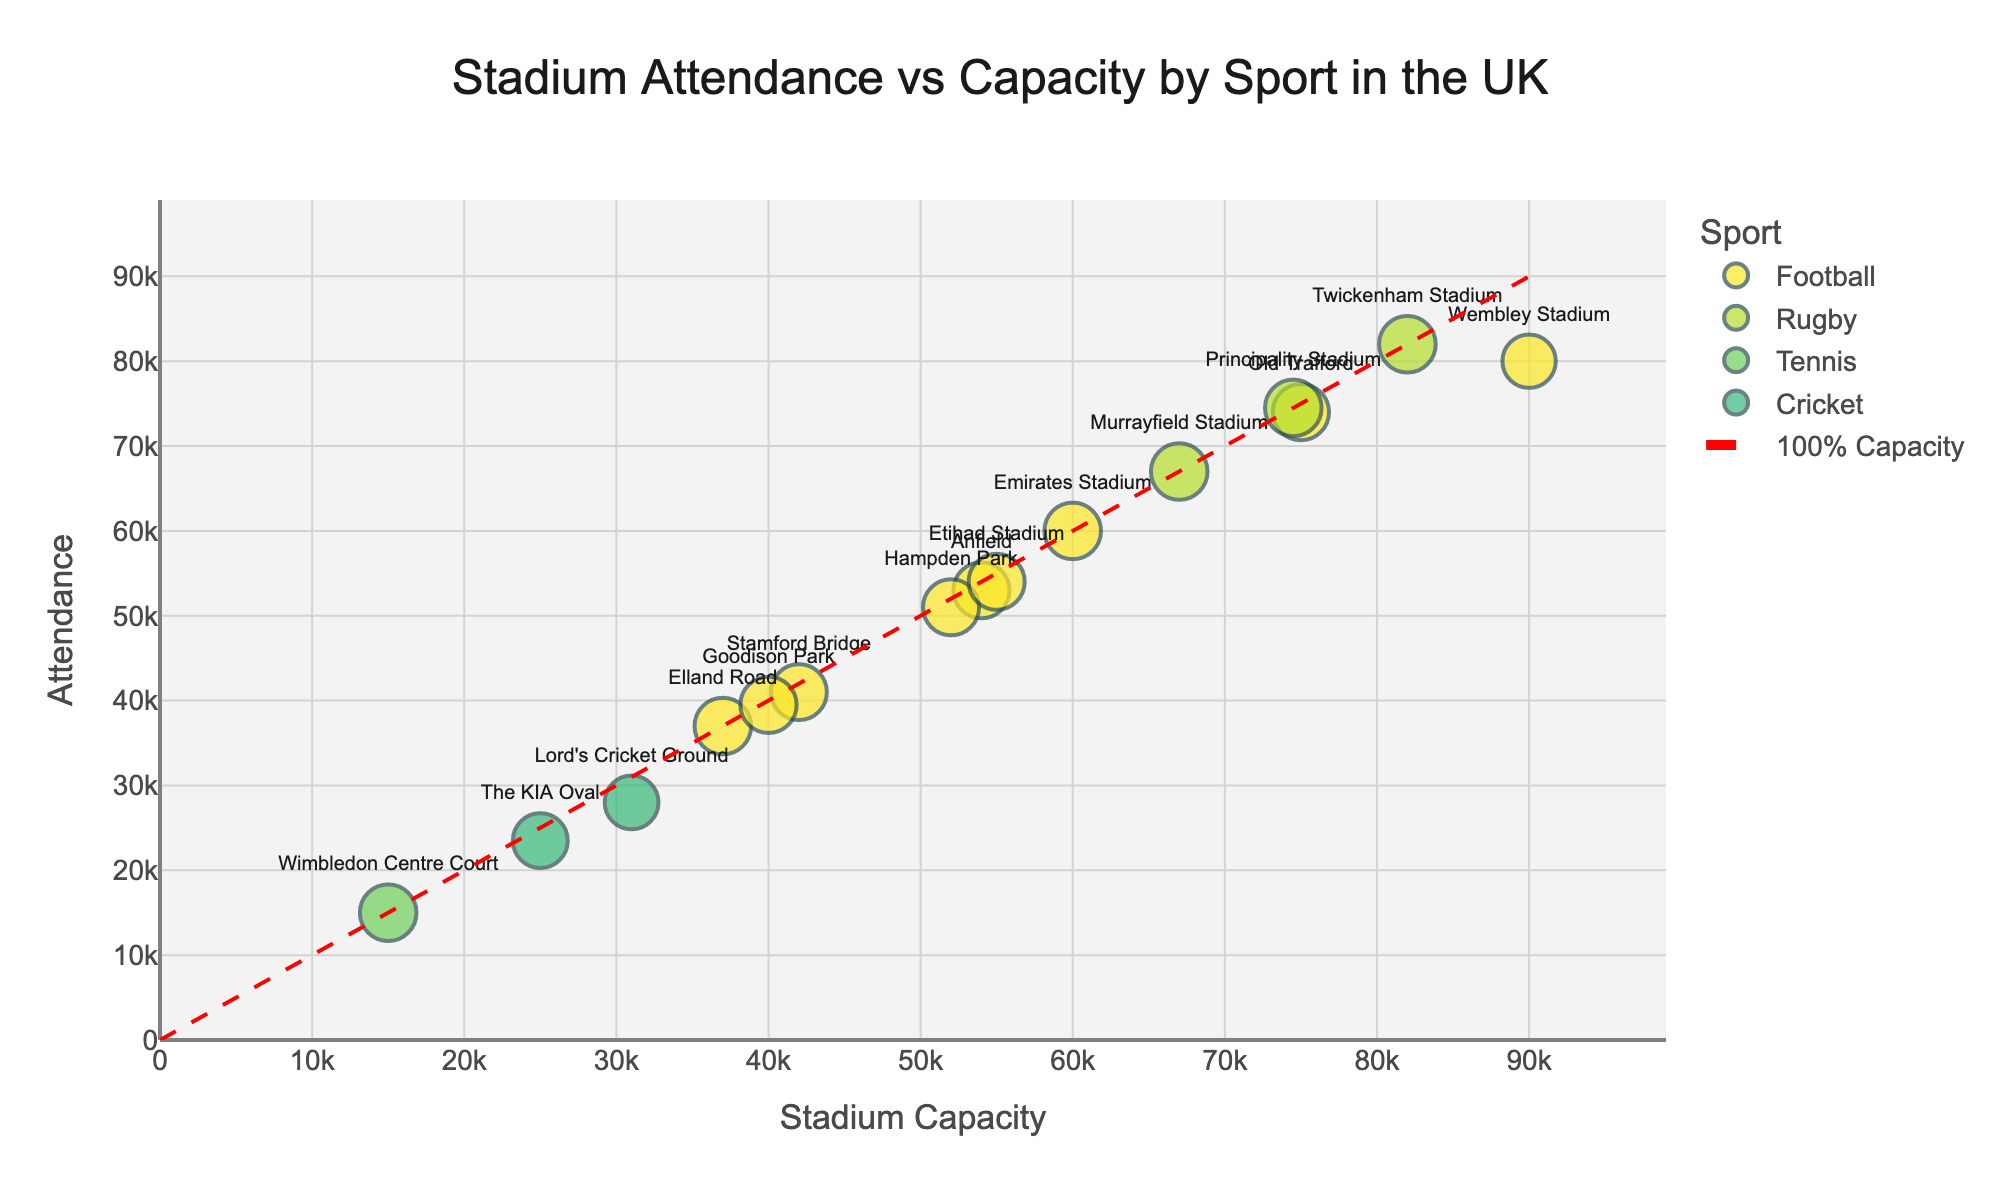What's the title of the grouped scatter plot? The title can be found prominently displayed at the top of the plot.
Answer: Stadium Attendance vs Capacity by Sport in the UK How many sports categories are represented in the plot? Each sport has a unique color. Identify the number of different colors in the legend.
Answer: Four (Football, Rugby, Tennis, Cricket) Which stadium has the highest attendance figure? By looking at the highest y-axis value of the data points, we can identify the stadium with the highest attendance.
Answer: Twickenham Stadium Is there any sport category where all represented stadiums filled 100% of their capacity? Check the data points with 100% capacity filled (diagonal line) and see if all stadiums for any sport fall on this line.
Answer: Tennis (Wimbledon Centre Court) Which stadium had the lowest percentage of its capacity filled, and what was that percentage? Find the data point farthest below the 100% capacity diagonal line. The percentage is also indicated by the size of the point (smaller size indicates lower capacity filled).
Answer: Lord's Cricket Ground, 90.32% Compare the attendance of Wembley Stadium to Old Trafford during the 2022/2023 season. Which was higher and by how much? Look at the y-axis values of both points during the 2022/2023 season for Football. Subtract the smaller from the larger value.
Answer: Wembley Stadium by 6000 Which rugby stadium had the highest attendance? Identify the highest point within the Rugby category.
Answer: Twickenham Stadium How does the attendance at the Emirates Stadium compare to that at Anfield? Check the y-axis values for both data points and compare them.
Answer: Higher at the Emirates Stadium (60000 vs 53000) What is the average attendance for cricket stadiums? Sum up the attendance figures for Lord's Cricket Ground and The KIA Oval, and then divide by 2.
Answer: (28000 + 23500) / 2 = 25750 Which football stadium had the closest attendance to its capacity? Identify the football stadium data point that lies closest to the 100% capacity diagonal line.
Answer: Emirates Stadium (100% capacity filled) 